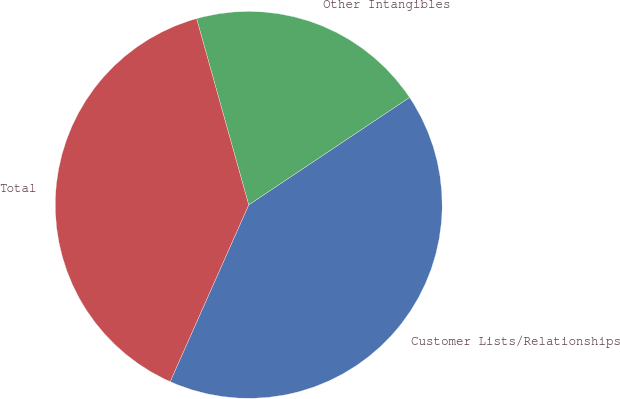<chart> <loc_0><loc_0><loc_500><loc_500><pie_chart><fcel>Customer Lists/Relationships<fcel>Other Intangibles<fcel>Total<nl><fcel>41.03%<fcel>19.97%<fcel>39.0%<nl></chart> 